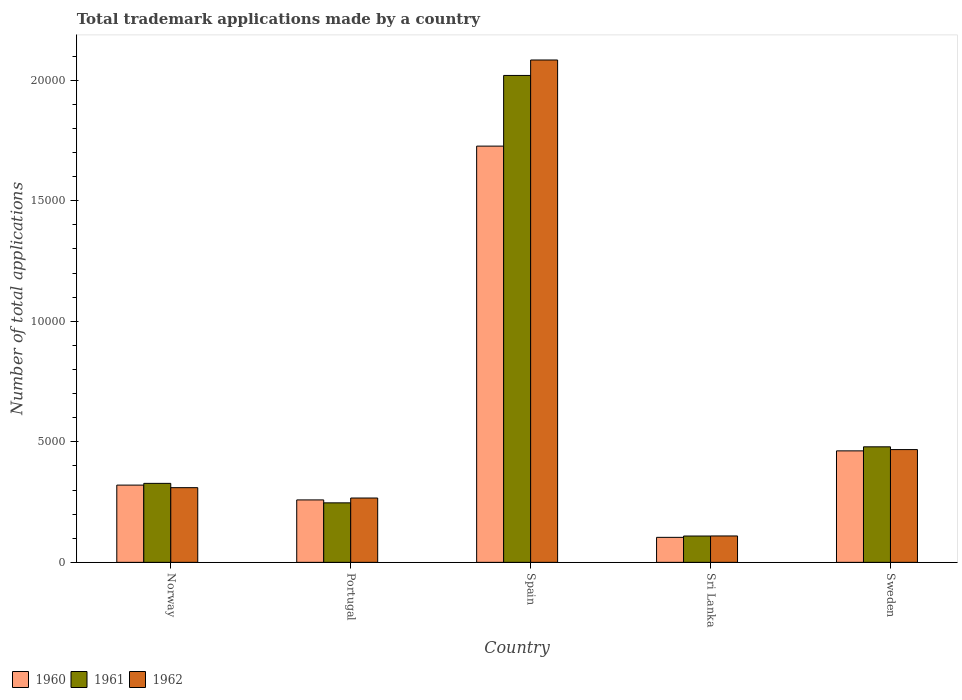How many different coloured bars are there?
Your answer should be very brief. 3. How many groups of bars are there?
Offer a terse response. 5. Are the number of bars per tick equal to the number of legend labels?
Your response must be concise. Yes. Are the number of bars on each tick of the X-axis equal?
Provide a short and direct response. Yes. How many bars are there on the 2nd tick from the left?
Offer a terse response. 3. What is the number of applications made by in 1962 in Norway?
Your response must be concise. 3098. Across all countries, what is the maximum number of applications made by in 1961?
Your answer should be compact. 2.02e+04. Across all countries, what is the minimum number of applications made by in 1960?
Your answer should be very brief. 1037. In which country was the number of applications made by in 1960 minimum?
Offer a terse response. Sri Lanka. What is the total number of applications made by in 1962 in the graph?
Provide a succinct answer. 3.24e+04. What is the difference between the number of applications made by in 1960 in Norway and that in Portugal?
Your answer should be very brief. 614. What is the difference between the number of applications made by in 1961 in Norway and the number of applications made by in 1962 in Portugal?
Your answer should be compact. 608. What is the average number of applications made by in 1961 per country?
Make the answer very short. 6364.4. What is the difference between the number of applications made by of/in 1962 and number of applications made by of/in 1961 in Sweden?
Ensure brevity in your answer.  -115. What is the ratio of the number of applications made by in 1962 in Sri Lanka to that in Sweden?
Offer a terse response. 0.23. What is the difference between the highest and the second highest number of applications made by in 1961?
Your answer should be very brief. -1.54e+04. What is the difference between the highest and the lowest number of applications made by in 1960?
Ensure brevity in your answer.  1.62e+04. In how many countries, is the number of applications made by in 1961 greater than the average number of applications made by in 1961 taken over all countries?
Your answer should be compact. 1. Is the sum of the number of applications made by in 1960 in Portugal and Sri Lanka greater than the maximum number of applications made by in 1961 across all countries?
Keep it short and to the point. No. What does the 1st bar from the left in Portugal represents?
Offer a terse response. 1960. Is it the case that in every country, the sum of the number of applications made by in 1961 and number of applications made by in 1960 is greater than the number of applications made by in 1962?
Your response must be concise. Yes. What is the difference between two consecutive major ticks on the Y-axis?
Provide a succinct answer. 5000. Does the graph contain any zero values?
Your response must be concise. No. Does the graph contain grids?
Your answer should be compact. No. Where does the legend appear in the graph?
Offer a terse response. Bottom left. What is the title of the graph?
Offer a terse response. Total trademark applications made by a country. Does "1999" appear as one of the legend labels in the graph?
Your answer should be compact. No. What is the label or title of the X-axis?
Offer a very short reply. Country. What is the label or title of the Y-axis?
Give a very brief answer. Number of total applications. What is the Number of total applications in 1960 in Norway?
Your response must be concise. 3204. What is the Number of total applications in 1961 in Norway?
Make the answer very short. 3276. What is the Number of total applications of 1962 in Norway?
Provide a short and direct response. 3098. What is the Number of total applications of 1960 in Portugal?
Offer a terse response. 2590. What is the Number of total applications of 1961 in Portugal?
Provide a short and direct response. 2468. What is the Number of total applications in 1962 in Portugal?
Ensure brevity in your answer.  2668. What is the Number of total applications in 1960 in Spain?
Provide a short and direct response. 1.73e+04. What is the Number of total applications in 1961 in Spain?
Give a very brief answer. 2.02e+04. What is the Number of total applications in 1962 in Spain?
Provide a succinct answer. 2.08e+04. What is the Number of total applications of 1960 in Sri Lanka?
Offer a very short reply. 1037. What is the Number of total applications of 1961 in Sri Lanka?
Provide a short and direct response. 1092. What is the Number of total applications of 1962 in Sri Lanka?
Keep it short and to the point. 1095. What is the Number of total applications of 1960 in Sweden?
Give a very brief answer. 4624. What is the Number of total applications of 1961 in Sweden?
Your answer should be compact. 4792. What is the Number of total applications in 1962 in Sweden?
Your response must be concise. 4677. Across all countries, what is the maximum Number of total applications of 1960?
Provide a succinct answer. 1.73e+04. Across all countries, what is the maximum Number of total applications in 1961?
Your answer should be very brief. 2.02e+04. Across all countries, what is the maximum Number of total applications of 1962?
Offer a very short reply. 2.08e+04. Across all countries, what is the minimum Number of total applications of 1960?
Give a very brief answer. 1037. Across all countries, what is the minimum Number of total applications in 1961?
Your response must be concise. 1092. Across all countries, what is the minimum Number of total applications in 1962?
Your answer should be very brief. 1095. What is the total Number of total applications in 1960 in the graph?
Offer a very short reply. 2.87e+04. What is the total Number of total applications of 1961 in the graph?
Provide a succinct answer. 3.18e+04. What is the total Number of total applications of 1962 in the graph?
Your answer should be very brief. 3.24e+04. What is the difference between the Number of total applications of 1960 in Norway and that in Portugal?
Your answer should be very brief. 614. What is the difference between the Number of total applications of 1961 in Norway and that in Portugal?
Make the answer very short. 808. What is the difference between the Number of total applications in 1962 in Norway and that in Portugal?
Offer a very short reply. 430. What is the difference between the Number of total applications of 1960 in Norway and that in Spain?
Give a very brief answer. -1.41e+04. What is the difference between the Number of total applications of 1961 in Norway and that in Spain?
Give a very brief answer. -1.69e+04. What is the difference between the Number of total applications in 1962 in Norway and that in Spain?
Your response must be concise. -1.77e+04. What is the difference between the Number of total applications of 1960 in Norway and that in Sri Lanka?
Your answer should be very brief. 2167. What is the difference between the Number of total applications in 1961 in Norway and that in Sri Lanka?
Keep it short and to the point. 2184. What is the difference between the Number of total applications of 1962 in Norway and that in Sri Lanka?
Your answer should be very brief. 2003. What is the difference between the Number of total applications of 1960 in Norway and that in Sweden?
Your answer should be very brief. -1420. What is the difference between the Number of total applications in 1961 in Norway and that in Sweden?
Your answer should be compact. -1516. What is the difference between the Number of total applications of 1962 in Norway and that in Sweden?
Give a very brief answer. -1579. What is the difference between the Number of total applications in 1960 in Portugal and that in Spain?
Offer a very short reply. -1.47e+04. What is the difference between the Number of total applications of 1961 in Portugal and that in Spain?
Provide a succinct answer. -1.77e+04. What is the difference between the Number of total applications of 1962 in Portugal and that in Spain?
Your answer should be very brief. -1.82e+04. What is the difference between the Number of total applications of 1960 in Portugal and that in Sri Lanka?
Your response must be concise. 1553. What is the difference between the Number of total applications of 1961 in Portugal and that in Sri Lanka?
Offer a terse response. 1376. What is the difference between the Number of total applications of 1962 in Portugal and that in Sri Lanka?
Your response must be concise. 1573. What is the difference between the Number of total applications of 1960 in Portugal and that in Sweden?
Provide a short and direct response. -2034. What is the difference between the Number of total applications in 1961 in Portugal and that in Sweden?
Provide a succinct answer. -2324. What is the difference between the Number of total applications of 1962 in Portugal and that in Sweden?
Provide a short and direct response. -2009. What is the difference between the Number of total applications of 1960 in Spain and that in Sri Lanka?
Your answer should be compact. 1.62e+04. What is the difference between the Number of total applications in 1961 in Spain and that in Sri Lanka?
Give a very brief answer. 1.91e+04. What is the difference between the Number of total applications in 1962 in Spain and that in Sri Lanka?
Give a very brief answer. 1.97e+04. What is the difference between the Number of total applications of 1960 in Spain and that in Sweden?
Give a very brief answer. 1.26e+04. What is the difference between the Number of total applications in 1961 in Spain and that in Sweden?
Your response must be concise. 1.54e+04. What is the difference between the Number of total applications in 1962 in Spain and that in Sweden?
Your response must be concise. 1.62e+04. What is the difference between the Number of total applications of 1960 in Sri Lanka and that in Sweden?
Make the answer very short. -3587. What is the difference between the Number of total applications of 1961 in Sri Lanka and that in Sweden?
Ensure brevity in your answer.  -3700. What is the difference between the Number of total applications of 1962 in Sri Lanka and that in Sweden?
Offer a very short reply. -3582. What is the difference between the Number of total applications in 1960 in Norway and the Number of total applications in 1961 in Portugal?
Provide a succinct answer. 736. What is the difference between the Number of total applications of 1960 in Norway and the Number of total applications of 1962 in Portugal?
Keep it short and to the point. 536. What is the difference between the Number of total applications in 1961 in Norway and the Number of total applications in 1962 in Portugal?
Offer a terse response. 608. What is the difference between the Number of total applications in 1960 in Norway and the Number of total applications in 1961 in Spain?
Provide a succinct answer. -1.70e+04. What is the difference between the Number of total applications in 1960 in Norway and the Number of total applications in 1962 in Spain?
Your answer should be compact. -1.76e+04. What is the difference between the Number of total applications of 1961 in Norway and the Number of total applications of 1962 in Spain?
Keep it short and to the point. -1.76e+04. What is the difference between the Number of total applications in 1960 in Norway and the Number of total applications in 1961 in Sri Lanka?
Your answer should be very brief. 2112. What is the difference between the Number of total applications of 1960 in Norway and the Number of total applications of 1962 in Sri Lanka?
Your response must be concise. 2109. What is the difference between the Number of total applications in 1961 in Norway and the Number of total applications in 1962 in Sri Lanka?
Offer a very short reply. 2181. What is the difference between the Number of total applications of 1960 in Norway and the Number of total applications of 1961 in Sweden?
Keep it short and to the point. -1588. What is the difference between the Number of total applications in 1960 in Norway and the Number of total applications in 1962 in Sweden?
Keep it short and to the point. -1473. What is the difference between the Number of total applications of 1961 in Norway and the Number of total applications of 1962 in Sweden?
Offer a very short reply. -1401. What is the difference between the Number of total applications in 1960 in Portugal and the Number of total applications in 1961 in Spain?
Your answer should be compact. -1.76e+04. What is the difference between the Number of total applications of 1960 in Portugal and the Number of total applications of 1962 in Spain?
Provide a short and direct response. -1.82e+04. What is the difference between the Number of total applications in 1961 in Portugal and the Number of total applications in 1962 in Spain?
Provide a succinct answer. -1.84e+04. What is the difference between the Number of total applications of 1960 in Portugal and the Number of total applications of 1961 in Sri Lanka?
Offer a very short reply. 1498. What is the difference between the Number of total applications in 1960 in Portugal and the Number of total applications in 1962 in Sri Lanka?
Offer a very short reply. 1495. What is the difference between the Number of total applications of 1961 in Portugal and the Number of total applications of 1962 in Sri Lanka?
Provide a succinct answer. 1373. What is the difference between the Number of total applications in 1960 in Portugal and the Number of total applications in 1961 in Sweden?
Provide a short and direct response. -2202. What is the difference between the Number of total applications in 1960 in Portugal and the Number of total applications in 1962 in Sweden?
Keep it short and to the point. -2087. What is the difference between the Number of total applications of 1961 in Portugal and the Number of total applications of 1962 in Sweden?
Give a very brief answer. -2209. What is the difference between the Number of total applications of 1960 in Spain and the Number of total applications of 1961 in Sri Lanka?
Provide a short and direct response. 1.62e+04. What is the difference between the Number of total applications in 1960 in Spain and the Number of total applications in 1962 in Sri Lanka?
Your answer should be very brief. 1.62e+04. What is the difference between the Number of total applications of 1961 in Spain and the Number of total applications of 1962 in Sri Lanka?
Make the answer very short. 1.91e+04. What is the difference between the Number of total applications in 1960 in Spain and the Number of total applications in 1961 in Sweden?
Make the answer very short. 1.25e+04. What is the difference between the Number of total applications in 1960 in Spain and the Number of total applications in 1962 in Sweden?
Give a very brief answer. 1.26e+04. What is the difference between the Number of total applications of 1961 in Spain and the Number of total applications of 1962 in Sweden?
Offer a very short reply. 1.55e+04. What is the difference between the Number of total applications in 1960 in Sri Lanka and the Number of total applications in 1961 in Sweden?
Provide a short and direct response. -3755. What is the difference between the Number of total applications in 1960 in Sri Lanka and the Number of total applications in 1962 in Sweden?
Provide a short and direct response. -3640. What is the difference between the Number of total applications in 1961 in Sri Lanka and the Number of total applications in 1962 in Sweden?
Keep it short and to the point. -3585. What is the average Number of total applications of 1960 per country?
Your answer should be compact. 5743.6. What is the average Number of total applications of 1961 per country?
Your answer should be very brief. 6364.4. What is the average Number of total applications in 1962 per country?
Give a very brief answer. 6474.6. What is the difference between the Number of total applications of 1960 and Number of total applications of 1961 in Norway?
Offer a very short reply. -72. What is the difference between the Number of total applications in 1960 and Number of total applications in 1962 in Norway?
Your answer should be very brief. 106. What is the difference between the Number of total applications in 1961 and Number of total applications in 1962 in Norway?
Your answer should be very brief. 178. What is the difference between the Number of total applications in 1960 and Number of total applications in 1961 in Portugal?
Provide a succinct answer. 122. What is the difference between the Number of total applications of 1960 and Number of total applications of 1962 in Portugal?
Your response must be concise. -78. What is the difference between the Number of total applications in 1961 and Number of total applications in 1962 in Portugal?
Provide a succinct answer. -200. What is the difference between the Number of total applications of 1960 and Number of total applications of 1961 in Spain?
Offer a very short reply. -2931. What is the difference between the Number of total applications in 1960 and Number of total applications in 1962 in Spain?
Make the answer very short. -3572. What is the difference between the Number of total applications of 1961 and Number of total applications of 1962 in Spain?
Offer a very short reply. -641. What is the difference between the Number of total applications in 1960 and Number of total applications in 1961 in Sri Lanka?
Give a very brief answer. -55. What is the difference between the Number of total applications of 1960 and Number of total applications of 1962 in Sri Lanka?
Your answer should be compact. -58. What is the difference between the Number of total applications in 1960 and Number of total applications in 1961 in Sweden?
Provide a succinct answer. -168. What is the difference between the Number of total applications in 1960 and Number of total applications in 1962 in Sweden?
Your answer should be compact. -53. What is the difference between the Number of total applications in 1961 and Number of total applications in 1962 in Sweden?
Provide a succinct answer. 115. What is the ratio of the Number of total applications of 1960 in Norway to that in Portugal?
Give a very brief answer. 1.24. What is the ratio of the Number of total applications of 1961 in Norway to that in Portugal?
Ensure brevity in your answer.  1.33. What is the ratio of the Number of total applications in 1962 in Norway to that in Portugal?
Keep it short and to the point. 1.16. What is the ratio of the Number of total applications of 1960 in Norway to that in Spain?
Keep it short and to the point. 0.19. What is the ratio of the Number of total applications of 1961 in Norway to that in Spain?
Provide a short and direct response. 0.16. What is the ratio of the Number of total applications in 1962 in Norway to that in Spain?
Provide a succinct answer. 0.15. What is the ratio of the Number of total applications in 1960 in Norway to that in Sri Lanka?
Your answer should be compact. 3.09. What is the ratio of the Number of total applications of 1962 in Norway to that in Sri Lanka?
Offer a very short reply. 2.83. What is the ratio of the Number of total applications in 1960 in Norway to that in Sweden?
Your answer should be very brief. 0.69. What is the ratio of the Number of total applications in 1961 in Norway to that in Sweden?
Your answer should be very brief. 0.68. What is the ratio of the Number of total applications in 1962 in Norway to that in Sweden?
Offer a terse response. 0.66. What is the ratio of the Number of total applications in 1960 in Portugal to that in Spain?
Ensure brevity in your answer.  0.15. What is the ratio of the Number of total applications in 1961 in Portugal to that in Spain?
Keep it short and to the point. 0.12. What is the ratio of the Number of total applications in 1962 in Portugal to that in Spain?
Offer a terse response. 0.13. What is the ratio of the Number of total applications in 1960 in Portugal to that in Sri Lanka?
Provide a succinct answer. 2.5. What is the ratio of the Number of total applications in 1961 in Portugal to that in Sri Lanka?
Provide a succinct answer. 2.26. What is the ratio of the Number of total applications in 1962 in Portugal to that in Sri Lanka?
Your response must be concise. 2.44. What is the ratio of the Number of total applications of 1960 in Portugal to that in Sweden?
Your answer should be compact. 0.56. What is the ratio of the Number of total applications in 1961 in Portugal to that in Sweden?
Offer a terse response. 0.52. What is the ratio of the Number of total applications of 1962 in Portugal to that in Sweden?
Make the answer very short. 0.57. What is the ratio of the Number of total applications in 1960 in Spain to that in Sri Lanka?
Offer a terse response. 16.65. What is the ratio of the Number of total applications in 1961 in Spain to that in Sri Lanka?
Provide a succinct answer. 18.49. What is the ratio of the Number of total applications of 1962 in Spain to that in Sri Lanka?
Provide a succinct answer. 19.03. What is the ratio of the Number of total applications in 1960 in Spain to that in Sweden?
Your answer should be very brief. 3.73. What is the ratio of the Number of total applications in 1961 in Spain to that in Sweden?
Your response must be concise. 4.21. What is the ratio of the Number of total applications of 1962 in Spain to that in Sweden?
Provide a short and direct response. 4.45. What is the ratio of the Number of total applications in 1960 in Sri Lanka to that in Sweden?
Your answer should be compact. 0.22. What is the ratio of the Number of total applications of 1961 in Sri Lanka to that in Sweden?
Offer a terse response. 0.23. What is the ratio of the Number of total applications in 1962 in Sri Lanka to that in Sweden?
Your response must be concise. 0.23. What is the difference between the highest and the second highest Number of total applications of 1960?
Provide a succinct answer. 1.26e+04. What is the difference between the highest and the second highest Number of total applications of 1961?
Offer a very short reply. 1.54e+04. What is the difference between the highest and the second highest Number of total applications of 1962?
Offer a very short reply. 1.62e+04. What is the difference between the highest and the lowest Number of total applications in 1960?
Keep it short and to the point. 1.62e+04. What is the difference between the highest and the lowest Number of total applications of 1961?
Make the answer very short. 1.91e+04. What is the difference between the highest and the lowest Number of total applications in 1962?
Offer a terse response. 1.97e+04. 